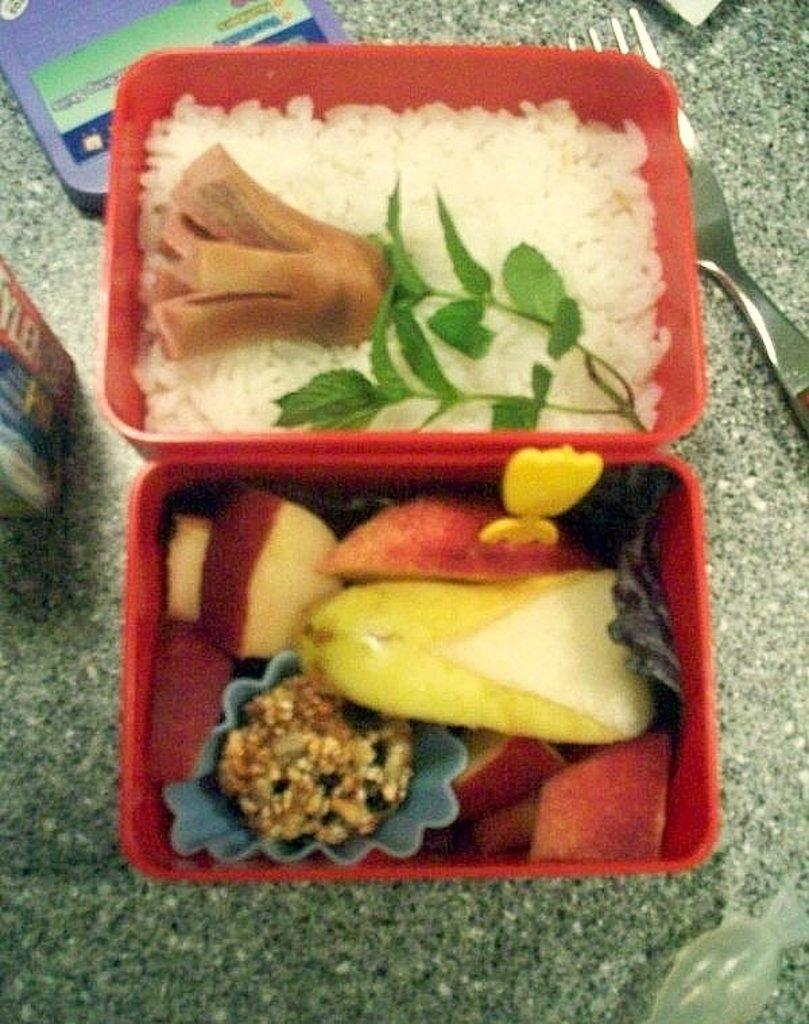What is the main object in the image? There is a lunch box in the image. What is inside the lunch box? The lunch box contains rice, sausage, mint leaves, and fruits. What utensil can be seen in the background of the image? There is a fork in the background of the image. What other object is present in the background of the image? There is a container in the background of the image. How many goldfish are swimming in the lunch box? There are no goldfish present in the image; it features a lunch box with various food items. What type of jail can be seen in the image? There is no jail present in the image; it features a lunch box and related objects. 